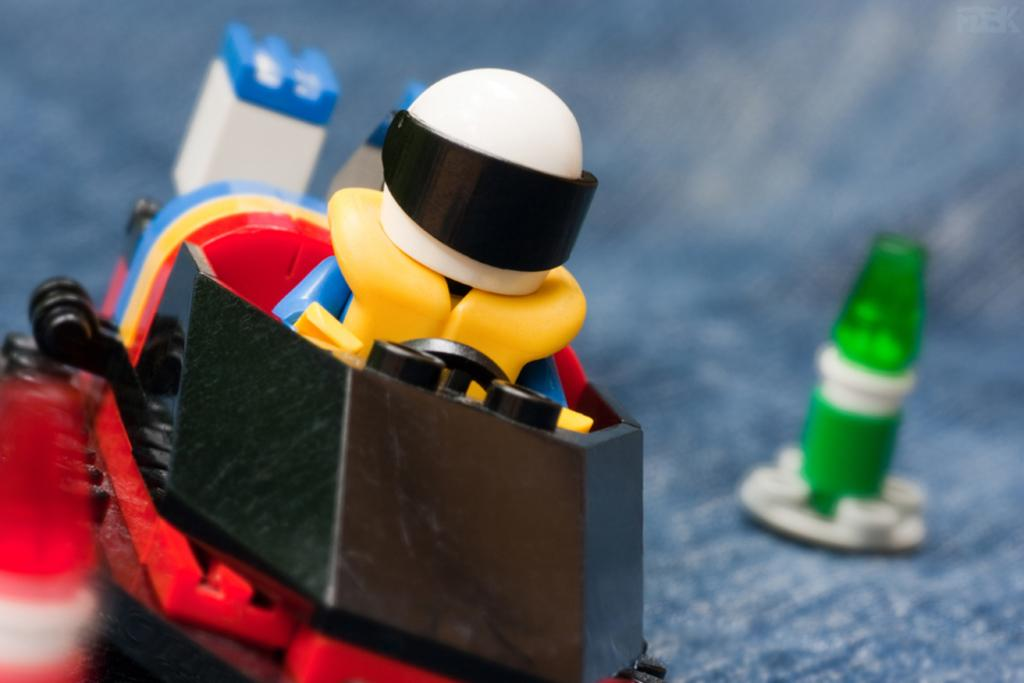What type of toy is in the image? There is a toy vehicle in the image. What colors can be seen on the toy vehicle? The toy vehicle has different colors: yellow, blue, red, white, and black. What else can be seen on the right side of the image? There is another toy on the right side of the image. What type of suit is the toy vehicle wearing in the image? There is no suit present in the image, as the subject is a toy vehicle and not a person. 